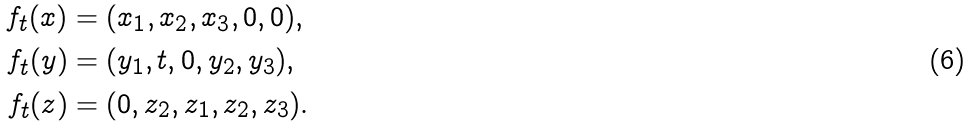Convert formula to latex. <formula><loc_0><loc_0><loc_500><loc_500>f _ { t } ( x ) & = ( x _ { 1 } , x _ { 2 } , x _ { 3 } , 0 , 0 ) , \\ f _ { t } ( y ) & = ( y _ { 1 } , t , 0 , y _ { 2 } , y _ { 3 } ) , \\ f _ { t } ( z ) & = ( 0 , z _ { 2 } , z _ { 1 } , z _ { 2 } , z _ { 3 } ) .</formula> 